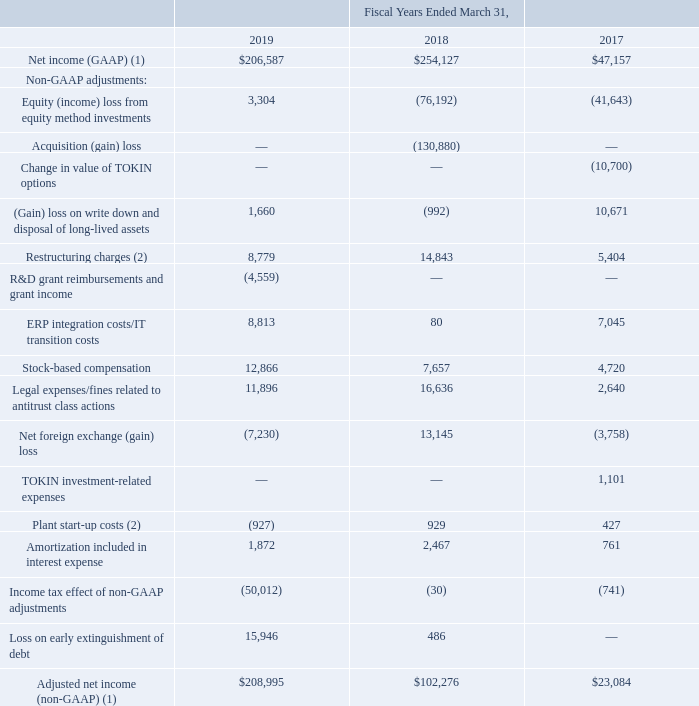The following table provides a reconciliation from U.S. GAAP Net income to non-GAAP Adjusted net income (amounts in thousands):
(1) Fiscal years ending March 31, 2018 and 2017 adjusted due to the adoption of ASC 606.
(2) $0.9 million in costs incurred during fiscal year 2018 related to the relocation of the Company's tantalum powder facility equipment from Carson City, Nevada to its existing Matamoros, Mexico plant were reclassified from “Plant start-up costs” to “Restructuring charges” during fiscal year 2019.
What was the net income (GAAP) in 2019?
Answer scale should be: thousand. 206,587. What was the Acquisition (gain) loss in 2018?
Answer scale should be: thousand. (130,880). What were the restructuring charges in 2017?
Answer scale should be: thousand. 5,404. How many years did restructuring charges exceed $10,000 thousand? 2018
Answer: 1. What was the change in the Legal expenses/fines related to antitrust class actions between 2017 and 2018?
Answer scale should be: thousand. 16,636-2,640
Answer: 13996. What was the percentage change in the Amortization included in interest expense between 2017 and 2019?
Answer scale should be: percent. (1,872-761)/761
Answer: 145.99. 